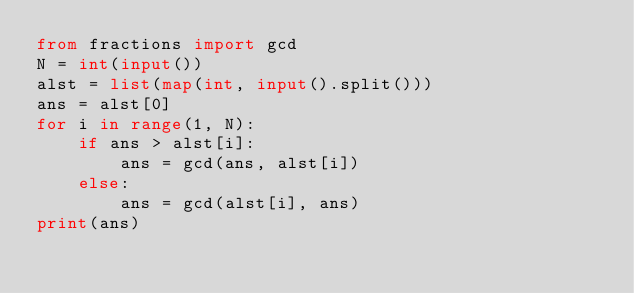<code> <loc_0><loc_0><loc_500><loc_500><_Python_>from fractions import gcd
N = int(input())
alst = list(map(int, input().split()))
ans = alst[0]
for i in range(1, N):
    if ans > alst[i]:
        ans = gcd(ans, alst[i])
    else:
        ans = gcd(alst[i], ans)
print(ans)
</code> 